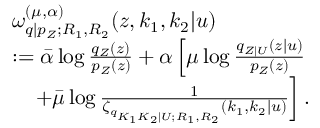Convert formula to latex. <formula><loc_0><loc_0><loc_500><loc_500>\begin{array} { r l } & { \omega _ { q | p _ { Z } ; R _ { 1 } , R _ { 2 } } ^ { ( \mu , \alpha ) } ( { z } , k _ { 1 } , k _ { 2 } | u ) } \\ & { \colon = \bar { \alpha } \log \frac { q _ { Z } ( { z } ) } { p _ { Z } ( { z } ) } + \alpha \left [ { \mu } \log \frac { q _ { { Z } | U } ( { z } | u ) } { p _ { Z } ( { z } ) } } \\ & { \quad + \bar { \mu } \log \frac { 1 } { \zeta _ { q _ { K _ { 1 } K _ { 2 } | U ; R _ { 1 } , R _ { 2 } } } ( k _ { 1 } , k _ { 2 } | u ) } \right ] . } \end{array}</formula> 